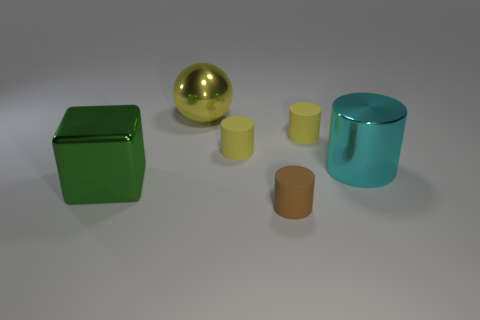Subtract all brown cylinders. How many cylinders are left? 3 Subtract all gray balls. How many yellow cylinders are left? 2 Add 3 small yellow cylinders. How many objects exist? 9 Subtract 2 cylinders. How many cylinders are left? 2 Subtract all cylinders. How many objects are left? 2 Subtract all yellow cylinders. How many cylinders are left? 2 Add 2 tiny brown cylinders. How many tiny brown cylinders exist? 3 Subtract 0 green balls. How many objects are left? 6 Subtract all brown blocks. Subtract all blue cylinders. How many blocks are left? 1 Subtract all cyan metal cylinders. Subtract all big things. How many objects are left? 2 